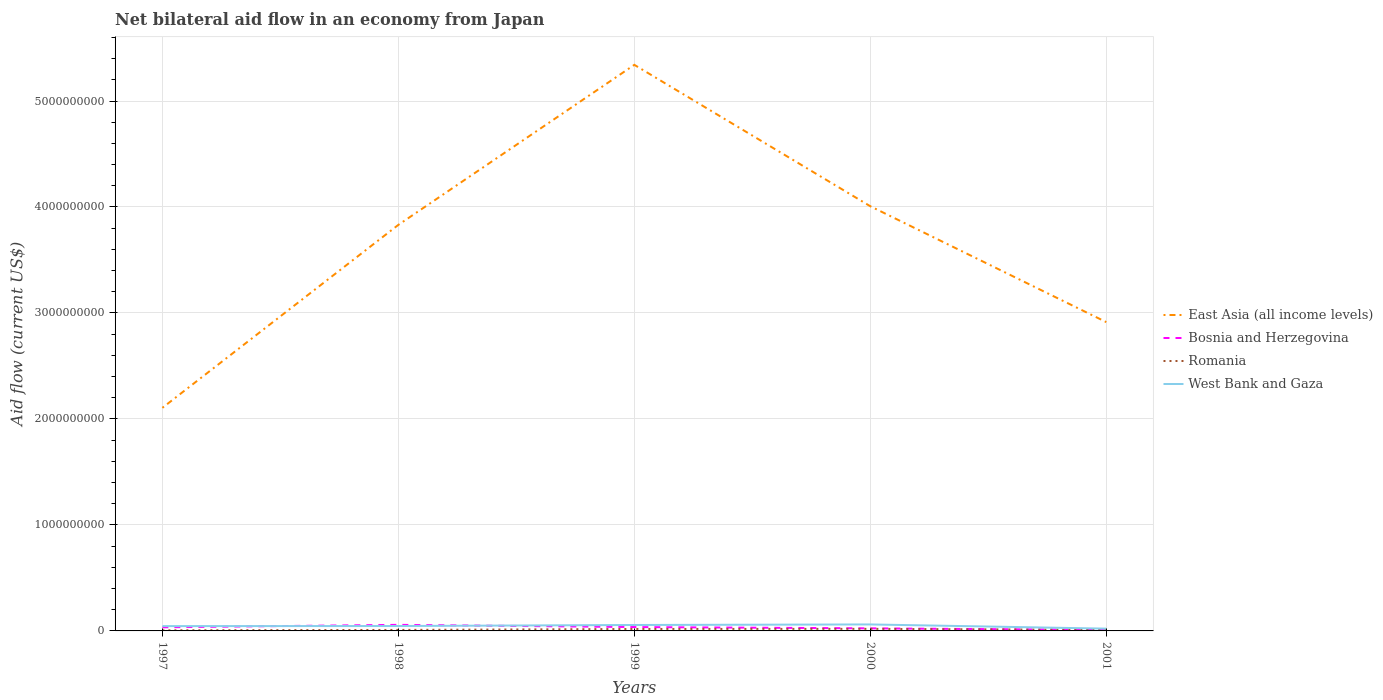Across all years, what is the maximum net bilateral aid flow in West Bank and Gaza?
Ensure brevity in your answer.  2.15e+07. In which year was the net bilateral aid flow in Bosnia and Herzegovina maximum?
Your answer should be compact. 2001. What is the total net bilateral aid flow in West Bank and Gaza in the graph?
Provide a short and direct response. 3.96e+07. What is the difference between the highest and the second highest net bilateral aid flow in Bosnia and Herzegovina?
Ensure brevity in your answer.  4.76e+07. How many lines are there?
Ensure brevity in your answer.  4. What is the difference between two consecutive major ticks on the Y-axis?
Your answer should be compact. 1.00e+09. Does the graph contain any zero values?
Offer a terse response. No. Where does the legend appear in the graph?
Your answer should be very brief. Center right. How many legend labels are there?
Offer a very short reply. 4. What is the title of the graph?
Your response must be concise. Net bilateral aid flow in an economy from Japan. What is the label or title of the Y-axis?
Provide a short and direct response. Aid flow (current US$). What is the Aid flow (current US$) in East Asia (all income levels) in 1997?
Make the answer very short. 2.11e+09. What is the Aid flow (current US$) of Bosnia and Herzegovina in 1997?
Your response must be concise. 3.42e+07. What is the Aid flow (current US$) of Romania in 1997?
Your response must be concise. 5.91e+06. What is the Aid flow (current US$) of West Bank and Gaza in 1997?
Your response must be concise. 4.55e+07. What is the Aid flow (current US$) of East Asia (all income levels) in 1998?
Keep it short and to the point. 3.83e+09. What is the Aid flow (current US$) of Bosnia and Herzegovina in 1998?
Offer a terse response. 5.73e+07. What is the Aid flow (current US$) in Romania in 1998?
Give a very brief answer. 9.31e+06. What is the Aid flow (current US$) of West Bank and Gaza in 1998?
Offer a very short reply. 4.63e+07. What is the Aid flow (current US$) of East Asia (all income levels) in 1999?
Make the answer very short. 5.34e+09. What is the Aid flow (current US$) of Bosnia and Herzegovina in 1999?
Your response must be concise. 3.64e+07. What is the Aid flow (current US$) of Romania in 1999?
Make the answer very short. 1.83e+07. What is the Aid flow (current US$) of West Bank and Gaza in 1999?
Give a very brief answer. 5.61e+07. What is the Aid flow (current US$) in East Asia (all income levels) in 2000?
Offer a terse response. 4.01e+09. What is the Aid flow (current US$) in Bosnia and Herzegovina in 2000?
Offer a very short reply. 2.44e+07. What is the Aid flow (current US$) of Romania in 2000?
Your response must be concise. 1.95e+07. What is the Aid flow (current US$) of West Bank and Gaza in 2000?
Provide a short and direct response. 6.12e+07. What is the Aid flow (current US$) in East Asia (all income levels) in 2001?
Your answer should be very brief. 2.91e+09. What is the Aid flow (current US$) in Bosnia and Herzegovina in 2001?
Offer a terse response. 9.64e+06. What is the Aid flow (current US$) of Romania in 2001?
Provide a short and direct response. 9.67e+06. What is the Aid flow (current US$) in West Bank and Gaza in 2001?
Your response must be concise. 2.15e+07. Across all years, what is the maximum Aid flow (current US$) in East Asia (all income levels)?
Ensure brevity in your answer.  5.34e+09. Across all years, what is the maximum Aid flow (current US$) in Bosnia and Herzegovina?
Provide a short and direct response. 5.73e+07. Across all years, what is the maximum Aid flow (current US$) in Romania?
Give a very brief answer. 1.95e+07. Across all years, what is the maximum Aid flow (current US$) of West Bank and Gaza?
Your answer should be very brief. 6.12e+07. Across all years, what is the minimum Aid flow (current US$) of East Asia (all income levels)?
Keep it short and to the point. 2.11e+09. Across all years, what is the minimum Aid flow (current US$) of Bosnia and Herzegovina?
Provide a succinct answer. 9.64e+06. Across all years, what is the minimum Aid flow (current US$) of Romania?
Offer a terse response. 5.91e+06. Across all years, what is the minimum Aid flow (current US$) in West Bank and Gaza?
Offer a very short reply. 2.15e+07. What is the total Aid flow (current US$) of East Asia (all income levels) in the graph?
Your answer should be very brief. 1.82e+1. What is the total Aid flow (current US$) of Bosnia and Herzegovina in the graph?
Your answer should be very brief. 1.62e+08. What is the total Aid flow (current US$) in Romania in the graph?
Your response must be concise. 6.27e+07. What is the total Aid flow (current US$) of West Bank and Gaza in the graph?
Make the answer very short. 2.31e+08. What is the difference between the Aid flow (current US$) of East Asia (all income levels) in 1997 and that in 1998?
Provide a short and direct response. -1.73e+09. What is the difference between the Aid flow (current US$) of Bosnia and Herzegovina in 1997 and that in 1998?
Keep it short and to the point. -2.31e+07. What is the difference between the Aid flow (current US$) of Romania in 1997 and that in 1998?
Keep it short and to the point. -3.40e+06. What is the difference between the Aid flow (current US$) of West Bank and Gaza in 1997 and that in 1998?
Your answer should be compact. -8.40e+05. What is the difference between the Aid flow (current US$) in East Asia (all income levels) in 1997 and that in 1999?
Offer a very short reply. -3.24e+09. What is the difference between the Aid flow (current US$) of Bosnia and Herzegovina in 1997 and that in 1999?
Ensure brevity in your answer.  -2.23e+06. What is the difference between the Aid flow (current US$) in Romania in 1997 and that in 1999?
Your answer should be very brief. -1.24e+07. What is the difference between the Aid flow (current US$) of West Bank and Gaza in 1997 and that in 1999?
Give a very brief answer. -1.06e+07. What is the difference between the Aid flow (current US$) of East Asia (all income levels) in 1997 and that in 2000?
Offer a very short reply. -1.90e+09. What is the difference between the Aid flow (current US$) in Bosnia and Herzegovina in 1997 and that in 2000?
Ensure brevity in your answer.  9.81e+06. What is the difference between the Aid flow (current US$) of Romania in 1997 and that in 2000?
Give a very brief answer. -1.36e+07. What is the difference between the Aid flow (current US$) of West Bank and Gaza in 1997 and that in 2000?
Your answer should be compact. -1.57e+07. What is the difference between the Aid flow (current US$) of East Asia (all income levels) in 1997 and that in 2001?
Your answer should be compact. -8.09e+08. What is the difference between the Aid flow (current US$) of Bosnia and Herzegovina in 1997 and that in 2001?
Your answer should be compact. 2.45e+07. What is the difference between the Aid flow (current US$) in Romania in 1997 and that in 2001?
Give a very brief answer. -3.76e+06. What is the difference between the Aid flow (current US$) of West Bank and Gaza in 1997 and that in 2001?
Your answer should be very brief. 2.39e+07. What is the difference between the Aid flow (current US$) in East Asia (all income levels) in 1998 and that in 1999?
Your response must be concise. -1.51e+09. What is the difference between the Aid flow (current US$) in Bosnia and Herzegovina in 1998 and that in 1999?
Provide a succinct answer. 2.09e+07. What is the difference between the Aid flow (current US$) of Romania in 1998 and that in 1999?
Ensure brevity in your answer.  -9.03e+06. What is the difference between the Aid flow (current US$) of West Bank and Gaza in 1998 and that in 1999?
Keep it short and to the point. -9.78e+06. What is the difference between the Aid flow (current US$) of East Asia (all income levels) in 1998 and that in 2000?
Offer a very short reply. -1.76e+08. What is the difference between the Aid flow (current US$) of Bosnia and Herzegovina in 1998 and that in 2000?
Provide a succinct answer. 3.29e+07. What is the difference between the Aid flow (current US$) in Romania in 1998 and that in 2000?
Give a very brief answer. -1.02e+07. What is the difference between the Aid flow (current US$) of West Bank and Gaza in 1998 and that in 2000?
Give a very brief answer. -1.48e+07. What is the difference between the Aid flow (current US$) in East Asia (all income levels) in 1998 and that in 2001?
Make the answer very short. 9.18e+08. What is the difference between the Aid flow (current US$) of Bosnia and Herzegovina in 1998 and that in 2001?
Provide a short and direct response. 4.76e+07. What is the difference between the Aid flow (current US$) of Romania in 1998 and that in 2001?
Give a very brief answer. -3.60e+05. What is the difference between the Aid flow (current US$) in West Bank and Gaza in 1998 and that in 2001?
Your answer should be compact. 2.48e+07. What is the difference between the Aid flow (current US$) of East Asia (all income levels) in 1999 and that in 2000?
Provide a short and direct response. 1.33e+09. What is the difference between the Aid flow (current US$) of Bosnia and Herzegovina in 1999 and that in 2000?
Your response must be concise. 1.20e+07. What is the difference between the Aid flow (current US$) in Romania in 1999 and that in 2000?
Provide a short and direct response. -1.16e+06. What is the difference between the Aid flow (current US$) in West Bank and Gaza in 1999 and that in 2000?
Offer a terse response. -5.07e+06. What is the difference between the Aid flow (current US$) in East Asia (all income levels) in 1999 and that in 2001?
Your answer should be compact. 2.43e+09. What is the difference between the Aid flow (current US$) of Bosnia and Herzegovina in 1999 and that in 2001?
Your answer should be compact. 2.68e+07. What is the difference between the Aid flow (current US$) in Romania in 1999 and that in 2001?
Ensure brevity in your answer.  8.67e+06. What is the difference between the Aid flow (current US$) of West Bank and Gaza in 1999 and that in 2001?
Offer a terse response. 3.46e+07. What is the difference between the Aid flow (current US$) of East Asia (all income levels) in 2000 and that in 2001?
Provide a succinct answer. 1.09e+09. What is the difference between the Aid flow (current US$) in Bosnia and Herzegovina in 2000 and that in 2001?
Provide a short and direct response. 1.47e+07. What is the difference between the Aid flow (current US$) in Romania in 2000 and that in 2001?
Your response must be concise. 9.83e+06. What is the difference between the Aid flow (current US$) of West Bank and Gaza in 2000 and that in 2001?
Make the answer very short. 3.96e+07. What is the difference between the Aid flow (current US$) in East Asia (all income levels) in 1997 and the Aid flow (current US$) in Bosnia and Herzegovina in 1998?
Your answer should be very brief. 2.05e+09. What is the difference between the Aid flow (current US$) in East Asia (all income levels) in 1997 and the Aid flow (current US$) in Romania in 1998?
Give a very brief answer. 2.10e+09. What is the difference between the Aid flow (current US$) in East Asia (all income levels) in 1997 and the Aid flow (current US$) in West Bank and Gaza in 1998?
Ensure brevity in your answer.  2.06e+09. What is the difference between the Aid flow (current US$) of Bosnia and Herzegovina in 1997 and the Aid flow (current US$) of Romania in 1998?
Your answer should be compact. 2.49e+07. What is the difference between the Aid flow (current US$) in Bosnia and Herzegovina in 1997 and the Aid flow (current US$) in West Bank and Gaza in 1998?
Your answer should be compact. -1.21e+07. What is the difference between the Aid flow (current US$) in Romania in 1997 and the Aid flow (current US$) in West Bank and Gaza in 1998?
Provide a short and direct response. -4.04e+07. What is the difference between the Aid flow (current US$) in East Asia (all income levels) in 1997 and the Aid flow (current US$) in Bosnia and Herzegovina in 1999?
Your response must be concise. 2.07e+09. What is the difference between the Aid flow (current US$) in East Asia (all income levels) in 1997 and the Aid flow (current US$) in Romania in 1999?
Offer a very short reply. 2.09e+09. What is the difference between the Aid flow (current US$) of East Asia (all income levels) in 1997 and the Aid flow (current US$) of West Bank and Gaza in 1999?
Offer a terse response. 2.05e+09. What is the difference between the Aid flow (current US$) in Bosnia and Herzegovina in 1997 and the Aid flow (current US$) in Romania in 1999?
Provide a succinct answer. 1.58e+07. What is the difference between the Aid flow (current US$) in Bosnia and Herzegovina in 1997 and the Aid flow (current US$) in West Bank and Gaza in 1999?
Keep it short and to the point. -2.19e+07. What is the difference between the Aid flow (current US$) in Romania in 1997 and the Aid flow (current US$) in West Bank and Gaza in 1999?
Ensure brevity in your answer.  -5.02e+07. What is the difference between the Aid flow (current US$) of East Asia (all income levels) in 1997 and the Aid flow (current US$) of Bosnia and Herzegovina in 2000?
Your answer should be very brief. 2.08e+09. What is the difference between the Aid flow (current US$) in East Asia (all income levels) in 1997 and the Aid flow (current US$) in Romania in 2000?
Offer a terse response. 2.09e+09. What is the difference between the Aid flow (current US$) in East Asia (all income levels) in 1997 and the Aid flow (current US$) in West Bank and Gaza in 2000?
Provide a succinct answer. 2.04e+09. What is the difference between the Aid flow (current US$) of Bosnia and Herzegovina in 1997 and the Aid flow (current US$) of Romania in 2000?
Offer a very short reply. 1.47e+07. What is the difference between the Aid flow (current US$) of Bosnia and Herzegovina in 1997 and the Aid flow (current US$) of West Bank and Gaza in 2000?
Provide a short and direct response. -2.70e+07. What is the difference between the Aid flow (current US$) of Romania in 1997 and the Aid flow (current US$) of West Bank and Gaza in 2000?
Offer a terse response. -5.52e+07. What is the difference between the Aid flow (current US$) in East Asia (all income levels) in 1997 and the Aid flow (current US$) in Bosnia and Herzegovina in 2001?
Your response must be concise. 2.10e+09. What is the difference between the Aid flow (current US$) of East Asia (all income levels) in 1997 and the Aid flow (current US$) of Romania in 2001?
Keep it short and to the point. 2.10e+09. What is the difference between the Aid flow (current US$) of East Asia (all income levels) in 1997 and the Aid flow (current US$) of West Bank and Gaza in 2001?
Provide a short and direct response. 2.08e+09. What is the difference between the Aid flow (current US$) of Bosnia and Herzegovina in 1997 and the Aid flow (current US$) of Romania in 2001?
Give a very brief answer. 2.45e+07. What is the difference between the Aid flow (current US$) in Bosnia and Herzegovina in 1997 and the Aid flow (current US$) in West Bank and Gaza in 2001?
Provide a short and direct response. 1.26e+07. What is the difference between the Aid flow (current US$) in Romania in 1997 and the Aid flow (current US$) in West Bank and Gaza in 2001?
Make the answer very short. -1.56e+07. What is the difference between the Aid flow (current US$) of East Asia (all income levels) in 1998 and the Aid flow (current US$) of Bosnia and Herzegovina in 1999?
Keep it short and to the point. 3.79e+09. What is the difference between the Aid flow (current US$) in East Asia (all income levels) in 1998 and the Aid flow (current US$) in Romania in 1999?
Keep it short and to the point. 3.81e+09. What is the difference between the Aid flow (current US$) of East Asia (all income levels) in 1998 and the Aid flow (current US$) of West Bank and Gaza in 1999?
Provide a succinct answer. 3.78e+09. What is the difference between the Aid flow (current US$) of Bosnia and Herzegovina in 1998 and the Aid flow (current US$) of Romania in 1999?
Offer a very short reply. 3.90e+07. What is the difference between the Aid flow (current US$) in Bosnia and Herzegovina in 1998 and the Aid flow (current US$) in West Bank and Gaza in 1999?
Provide a succinct answer. 1.21e+06. What is the difference between the Aid flow (current US$) of Romania in 1998 and the Aid flow (current US$) of West Bank and Gaza in 1999?
Your answer should be compact. -4.68e+07. What is the difference between the Aid flow (current US$) in East Asia (all income levels) in 1998 and the Aid flow (current US$) in Bosnia and Herzegovina in 2000?
Make the answer very short. 3.81e+09. What is the difference between the Aid flow (current US$) in East Asia (all income levels) in 1998 and the Aid flow (current US$) in Romania in 2000?
Offer a very short reply. 3.81e+09. What is the difference between the Aid flow (current US$) of East Asia (all income levels) in 1998 and the Aid flow (current US$) of West Bank and Gaza in 2000?
Ensure brevity in your answer.  3.77e+09. What is the difference between the Aid flow (current US$) in Bosnia and Herzegovina in 1998 and the Aid flow (current US$) in Romania in 2000?
Your response must be concise. 3.78e+07. What is the difference between the Aid flow (current US$) of Bosnia and Herzegovina in 1998 and the Aid flow (current US$) of West Bank and Gaza in 2000?
Give a very brief answer. -3.86e+06. What is the difference between the Aid flow (current US$) in Romania in 1998 and the Aid flow (current US$) in West Bank and Gaza in 2000?
Your answer should be compact. -5.18e+07. What is the difference between the Aid flow (current US$) in East Asia (all income levels) in 1998 and the Aid flow (current US$) in Bosnia and Herzegovina in 2001?
Offer a terse response. 3.82e+09. What is the difference between the Aid flow (current US$) in East Asia (all income levels) in 1998 and the Aid flow (current US$) in Romania in 2001?
Keep it short and to the point. 3.82e+09. What is the difference between the Aid flow (current US$) in East Asia (all income levels) in 1998 and the Aid flow (current US$) in West Bank and Gaza in 2001?
Keep it short and to the point. 3.81e+09. What is the difference between the Aid flow (current US$) of Bosnia and Herzegovina in 1998 and the Aid flow (current US$) of Romania in 2001?
Provide a succinct answer. 4.76e+07. What is the difference between the Aid flow (current US$) in Bosnia and Herzegovina in 1998 and the Aid flow (current US$) in West Bank and Gaza in 2001?
Your response must be concise. 3.58e+07. What is the difference between the Aid flow (current US$) of Romania in 1998 and the Aid flow (current US$) of West Bank and Gaza in 2001?
Offer a terse response. -1.22e+07. What is the difference between the Aid flow (current US$) in East Asia (all income levels) in 1999 and the Aid flow (current US$) in Bosnia and Herzegovina in 2000?
Your response must be concise. 5.32e+09. What is the difference between the Aid flow (current US$) of East Asia (all income levels) in 1999 and the Aid flow (current US$) of Romania in 2000?
Ensure brevity in your answer.  5.32e+09. What is the difference between the Aid flow (current US$) of East Asia (all income levels) in 1999 and the Aid flow (current US$) of West Bank and Gaza in 2000?
Your answer should be compact. 5.28e+09. What is the difference between the Aid flow (current US$) of Bosnia and Herzegovina in 1999 and the Aid flow (current US$) of Romania in 2000?
Offer a very short reply. 1.69e+07. What is the difference between the Aid flow (current US$) in Bosnia and Herzegovina in 1999 and the Aid flow (current US$) in West Bank and Gaza in 2000?
Provide a succinct answer. -2.48e+07. What is the difference between the Aid flow (current US$) in Romania in 1999 and the Aid flow (current US$) in West Bank and Gaza in 2000?
Make the answer very short. -4.28e+07. What is the difference between the Aid flow (current US$) in East Asia (all income levels) in 1999 and the Aid flow (current US$) in Bosnia and Herzegovina in 2001?
Your response must be concise. 5.33e+09. What is the difference between the Aid flow (current US$) of East Asia (all income levels) in 1999 and the Aid flow (current US$) of Romania in 2001?
Ensure brevity in your answer.  5.33e+09. What is the difference between the Aid flow (current US$) in East Asia (all income levels) in 1999 and the Aid flow (current US$) in West Bank and Gaza in 2001?
Offer a terse response. 5.32e+09. What is the difference between the Aid flow (current US$) of Bosnia and Herzegovina in 1999 and the Aid flow (current US$) of Romania in 2001?
Keep it short and to the point. 2.67e+07. What is the difference between the Aid flow (current US$) in Bosnia and Herzegovina in 1999 and the Aid flow (current US$) in West Bank and Gaza in 2001?
Ensure brevity in your answer.  1.49e+07. What is the difference between the Aid flow (current US$) of Romania in 1999 and the Aid flow (current US$) of West Bank and Gaza in 2001?
Offer a terse response. -3.18e+06. What is the difference between the Aid flow (current US$) in East Asia (all income levels) in 2000 and the Aid flow (current US$) in Bosnia and Herzegovina in 2001?
Offer a very short reply. 4.00e+09. What is the difference between the Aid flow (current US$) in East Asia (all income levels) in 2000 and the Aid flow (current US$) in Romania in 2001?
Your response must be concise. 4.00e+09. What is the difference between the Aid flow (current US$) of East Asia (all income levels) in 2000 and the Aid flow (current US$) of West Bank and Gaza in 2001?
Offer a terse response. 3.99e+09. What is the difference between the Aid flow (current US$) of Bosnia and Herzegovina in 2000 and the Aid flow (current US$) of Romania in 2001?
Offer a very short reply. 1.47e+07. What is the difference between the Aid flow (current US$) of Bosnia and Herzegovina in 2000 and the Aid flow (current US$) of West Bank and Gaza in 2001?
Make the answer very short. 2.84e+06. What is the difference between the Aid flow (current US$) of Romania in 2000 and the Aid flow (current US$) of West Bank and Gaza in 2001?
Offer a very short reply. -2.02e+06. What is the average Aid flow (current US$) in East Asia (all income levels) per year?
Provide a succinct answer. 3.64e+09. What is the average Aid flow (current US$) in Bosnia and Herzegovina per year?
Your answer should be very brief. 3.24e+07. What is the average Aid flow (current US$) in Romania per year?
Give a very brief answer. 1.25e+07. What is the average Aid flow (current US$) in West Bank and Gaza per year?
Your answer should be compact. 4.61e+07. In the year 1997, what is the difference between the Aid flow (current US$) of East Asia (all income levels) and Aid flow (current US$) of Bosnia and Herzegovina?
Your answer should be compact. 2.07e+09. In the year 1997, what is the difference between the Aid flow (current US$) in East Asia (all income levels) and Aid flow (current US$) in Romania?
Offer a terse response. 2.10e+09. In the year 1997, what is the difference between the Aid flow (current US$) in East Asia (all income levels) and Aid flow (current US$) in West Bank and Gaza?
Make the answer very short. 2.06e+09. In the year 1997, what is the difference between the Aid flow (current US$) in Bosnia and Herzegovina and Aid flow (current US$) in Romania?
Ensure brevity in your answer.  2.83e+07. In the year 1997, what is the difference between the Aid flow (current US$) of Bosnia and Herzegovina and Aid flow (current US$) of West Bank and Gaza?
Give a very brief answer. -1.13e+07. In the year 1997, what is the difference between the Aid flow (current US$) in Romania and Aid flow (current US$) in West Bank and Gaza?
Provide a short and direct response. -3.96e+07. In the year 1998, what is the difference between the Aid flow (current US$) in East Asia (all income levels) and Aid flow (current US$) in Bosnia and Herzegovina?
Your answer should be very brief. 3.77e+09. In the year 1998, what is the difference between the Aid flow (current US$) of East Asia (all income levels) and Aid flow (current US$) of Romania?
Make the answer very short. 3.82e+09. In the year 1998, what is the difference between the Aid flow (current US$) in East Asia (all income levels) and Aid flow (current US$) in West Bank and Gaza?
Offer a very short reply. 3.78e+09. In the year 1998, what is the difference between the Aid flow (current US$) in Bosnia and Herzegovina and Aid flow (current US$) in Romania?
Offer a terse response. 4.80e+07. In the year 1998, what is the difference between the Aid flow (current US$) of Bosnia and Herzegovina and Aid flow (current US$) of West Bank and Gaza?
Make the answer very short. 1.10e+07. In the year 1998, what is the difference between the Aid flow (current US$) in Romania and Aid flow (current US$) in West Bank and Gaza?
Offer a terse response. -3.70e+07. In the year 1999, what is the difference between the Aid flow (current US$) of East Asia (all income levels) and Aid flow (current US$) of Bosnia and Herzegovina?
Provide a succinct answer. 5.30e+09. In the year 1999, what is the difference between the Aid flow (current US$) in East Asia (all income levels) and Aid flow (current US$) in Romania?
Offer a very short reply. 5.32e+09. In the year 1999, what is the difference between the Aid flow (current US$) of East Asia (all income levels) and Aid flow (current US$) of West Bank and Gaza?
Keep it short and to the point. 5.29e+09. In the year 1999, what is the difference between the Aid flow (current US$) in Bosnia and Herzegovina and Aid flow (current US$) in Romania?
Offer a terse response. 1.81e+07. In the year 1999, what is the difference between the Aid flow (current US$) of Bosnia and Herzegovina and Aid flow (current US$) of West Bank and Gaza?
Ensure brevity in your answer.  -1.97e+07. In the year 1999, what is the difference between the Aid flow (current US$) of Romania and Aid flow (current US$) of West Bank and Gaza?
Give a very brief answer. -3.77e+07. In the year 2000, what is the difference between the Aid flow (current US$) of East Asia (all income levels) and Aid flow (current US$) of Bosnia and Herzegovina?
Keep it short and to the point. 3.98e+09. In the year 2000, what is the difference between the Aid flow (current US$) in East Asia (all income levels) and Aid flow (current US$) in Romania?
Your answer should be compact. 3.99e+09. In the year 2000, what is the difference between the Aid flow (current US$) of East Asia (all income levels) and Aid flow (current US$) of West Bank and Gaza?
Ensure brevity in your answer.  3.95e+09. In the year 2000, what is the difference between the Aid flow (current US$) of Bosnia and Herzegovina and Aid flow (current US$) of Romania?
Ensure brevity in your answer.  4.86e+06. In the year 2000, what is the difference between the Aid flow (current US$) of Bosnia and Herzegovina and Aid flow (current US$) of West Bank and Gaza?
Your answer should be compact. -3.68e+07. In the year 2000, what is the difference between the Aid flow (current US$) in Romania and Aid flow (current US$) in West Bank and Gaza?
Provide a short and direct response. -4.16e+07. In the year 2001, what is the difference between the Aid flow (current US$) in East Asia (all income levels) and Aid flow (current US$) in Bosnia and Herzegovina?
Your response must be concise. 2.90e+09. In the year 2001, what is the difference between the Aid flow (current US$) of East Asia (all income levels) and Aid flow (current US$) of Romania?
Give a very brief answer. 2.90e+09. In the year 2001, what is the difference between the Aid flow (current US$) of East Asia (all income levels) and Aid flow (current US$) of West Bank and Gaza?
Provide a succinct answer. 2.89e+09. In the year 2001, what is the difference between the Aid flow (current US$) of Bosnia and Herzegovina and Aid flow (current US$) of Romania?
Provide a short and direct response. -3.00e+04. In the year 2001, what is the difference between the Aid flow (current US$) of Bosnia and Herzegovina and Aid flow (current US$) of West Bank and Gaza?
Offer a very short reply. -1.19e+07. In the year 2001, what is the difference between the Aid flow (current US$) of Romania and Aid flow (current US$) of West Bank and Gaza?
Keep it short and to the point. -1.18e+07. What is the ratio of the Aid flow (current US$) in East Asia (all income levels) in 1997 to that in 1998?
Your response must be concise. 0.55. What is the ratio of the Aid flow (current US$) in Bosnia and Herzegovina in 1997 to that in 1998?
Offer a very short reply. 0.6. What is the ratio of the Aid flow (current US$) in Romania in 1997 to that in 1998?
Your answer should be compact. 0.63. What is the ratio of the Aid flow (current US$) of West Bank and Gaza in 1997 to that in 1998?
Your response must be concise. 0.98. What is the ratio of the Aid flow (current US$) in East Asia (all income levels) in 1997 to that in 1999?
Offer a very short reply. 0.39. What is the ratio of the Aid flow (current US$) in Bosnia and Herzegovina in 1997 to that in 1999?
Give a very brief answer. 0.94. What is the ratio of the Aid flow (current US$) of Romania in 1997 to that in 1999?
Offer a very short reply. 0.32. What is the ratio of the Aid flow (current US$) of West Bank and Gaza in 1997 to that in 1999?
Ensure brevity in your answer.  0.81. What is the ratio of the Aid flow (current US$) of East Asia (all income levels) in 1997 to that in 2000?
Offer a terse response. 0.53. What is the ratio of the Aid flow (current US$) of Bosnia and Herzegovina in 1997 to that in 2000?
Your response must be concise. 1.4. What is the ratio of the Aid flow (current US$) of Romania in 1997 to that in 2000?
Your response must be concise. 0.3. What is the ratio of the Aid flow (current US$) of West Bank and Gaza in 1997 to that in 2000?
Provide a succinct answer. 0.74. What is the ratio of the Aid flow (current US$) of East Asia (all income levels) in 1997 to that in 2001?
Your response must be concise. 0.72. What is the ratio of the Aid flow (current US$) of Bosnia and Herzegovina in 1997 to that in 2001?
Provide a short and direct response. 3.54. What is the ratio of the Aid flow (current US$) of Romania in 1997 to that in 2001?
Provide a succinct answer. 0.61. What is the ratio of the Aid flow (current US$) in West Bank and Gaza in 1997 to that in 2001?
Provide a short and direct response. 2.11. What is the ratio of the Aid flow (current US$) in East Asia (all income levels) in 1998 to that in 1999?
Offer a terse response. 0.72. What is the ratio of the Aid flow (current US$) of Bosnia and Herzegovina in 1998 to that in 1999?
Provide a succinct answer. 1.57. What is the ratio of the Aid flow (current US$) in Romania in 1998 to that in 1999?
Provide a short and direct response. 0.51. What is the ratio of the Aid flow (current US$) of West Bank and Gaza in 1998 to that in 1999?
Offer a terse response. 0.83. What is the ratio of the Aid flow (current US$) of East Asia (all income levels) in 1998 to that in 2000?
Offer a terse response. 0.96. What is the ratio of the Aid flow (current US$) of Bosnia and Herzegovina in 1998 to that in 2000?
Offer a very short reply. 2.35. What is the ratio of the Aid flow (current US$) in Romania in 1998 to that in 2000?
Offer a terse response. 0.48. What is the ratio of the Aid flow (current US$) of West Bank and Gaza in 1998 to that in 2000?
Provide a succinct answer. 0.76. What is the ratio of the Aid flow (current US$) in East Asia (all income levels) in 1998 to that in 2001?
Provide a short and direct response. 1.31. What is the ratio of the Aid flow (current US$) in Bosnia and Herzegovina in 1998 to that in 2001?
Make the answer very short. 5.94. What is the ratio of the Aid flow (current US$) in Romania in 1998 to that in 2001?
Offer a very short reply. 0.96. What is the ratio of the Aid flow (current US$) of West Bank and Gaza in 1998 to that in 2001?
Your answer should be very brief. 2.15. What is the ratio of the Aid flow (current US$) in East Asia (all income levels) in 1999 to that in 2000?
Provide a short and direct response. 1.33. What is the ratio of the Aid flow (current US$) in Bosnia and Herzegovina in 1999 to that in 2000?
Offer a very short reply. 1.49. What is the ratio of the Aid flow (current US$) in Romania in 1999 to that in 2000?
Your response must be concise. 0.94. What is the ratio of the Aid flow (current US$) in West Bank and Gaza in 1999 to that in 2000?
Your answer should be very brief. 0.92. What is the ratio of the Aid flow (current US$) of East Asia (all income levels) in 1999 to that in 2001?
Your response must be concise. 1.83. What is the ratio of the Aid flow (current US$) of Bosnia and Herzegovina in 1999 to that in 2001?
Give a very brief answer. 3.78. What is the ratio of the Aid flow (current US$) in Romania in 1999 to that in 2001?
Give a very brief answer. 1.9. What is the ratio of the Aid flow (current US$) in West Bank and Gaza in 1999 to that in 2001?
Offer a very short reply. 2.61. What is the ratio of the Aid flow (current US$) in East Asia (all income levels) in 2000 to that in 2001?
Offer a very short reply. 1.38. What is the ratio of the Aid flow (current US$) of Bosnia and Herzegovina in 2000 to that in 2001?
Your answer should be compact. 2.53. What is the ratio of the Aid flow (current US$) of Romania in 2000 to that in 2001?
Provide a succinct answer. 2.02. What is the ratio of the Aid flow (current US$) in West Bank and Gaza in 2000 to that in 2001?
Your answer should be compact. 2.84. What is the difference between the highest and the second highest Aid flow (current US$) of East Asia (all income levels)?
Make the answer very short. 1.33e+09. What is the difference between the highest and the second highest Aid flow (current US$) of Bosnia and Herzegovina?
Ensure brevity in your answer.  2.09e+07. What is the difference between the highest and the second highest Aid flow (current US$) of Romania?
Provide a short and direct response. 1.16e+06. What is the difference between the highest and the second highest Aid flow (current US$) in West Bank and Gaza?
Your response must be concise. 5.07e+06. What is the difference between the highest and the lowest Aid flow (current US$) in East Asia (all income levels)?
Offer a very short reply. 3.24e+09. What is the difference between the highest and the lowest Aid flow (current US$) of Bosnia and Herzegovina?
Offer a terse response. 4.76e+07. What is the difference between the highest and the lowest Aid flow (current US$) in Romania?
Provide a short and direct response. 1.36e+07. What is the difference between the highest and the lowest Aid flow (current US$) of West Bank and Gaza?
Provide a succinct answer. 3.96e+07. 